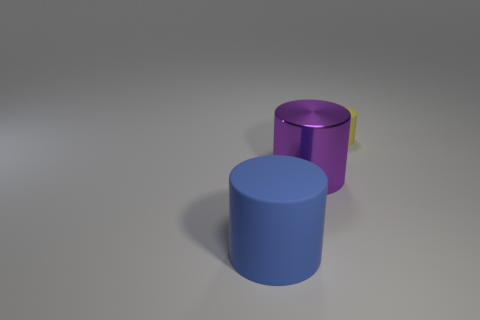How many things are either rubber objects left of the yellow thing or small yellow shiny cylinders?
Provide a succinct answer. 1. What number of yellow objects are the same material as the big purple cylinder?
Give a very brief answer. 0. Are there any big matte things of the same shape as the tiny object?
Ensure brevity in your answer.  Yes. What is the shape of the other object that is the same size as the blue thing?
Offer a very short reply. Cylinder. What number of purple shiny objects are behind the rubber cylinder that is to the left of the yellow matte thing?
Make the answer very short. 1. Are there any blue cylinders of the same size as the purple thing?
Offer a terse response. Yes. Is the number of big cylinders that are in front of the large metallic cylinder greater than the number of yellow objects that are in front of the tiny yellow matte cylinder?
Your answer should be very brief. Yes. Does the tiny cylinder have the same material as the cylinder that is in front of the purple cylinder?
Offer a very short reply. Yes. How many big purple things are in front of the yellow matte object that is right of the rubber object in front of the yellow cylinder?
Ensure brevity in your answer.  1. There is a tiny matte thing; is it the same shape as the large object left of the big metallic object?
Ensure brevity in your answer.  Yes. 